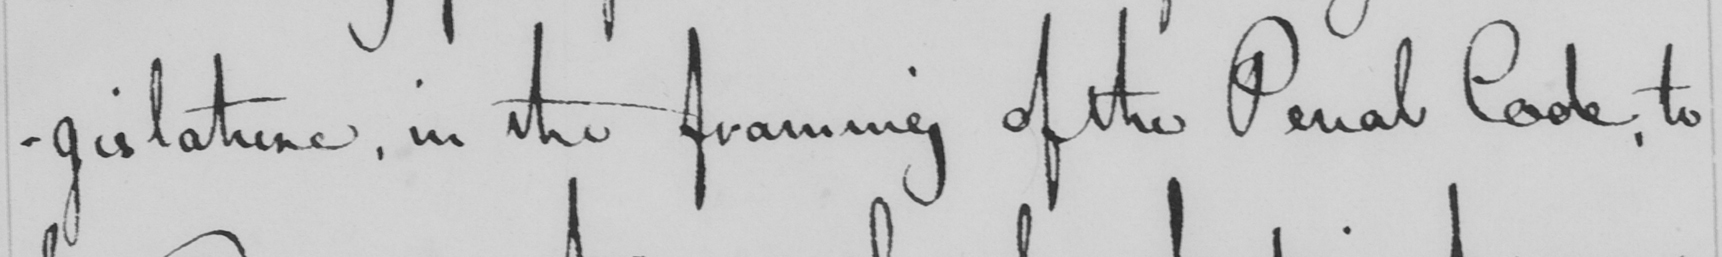What is written in this line of handwriting? -gislature, in the framing of the Penal Code, to 